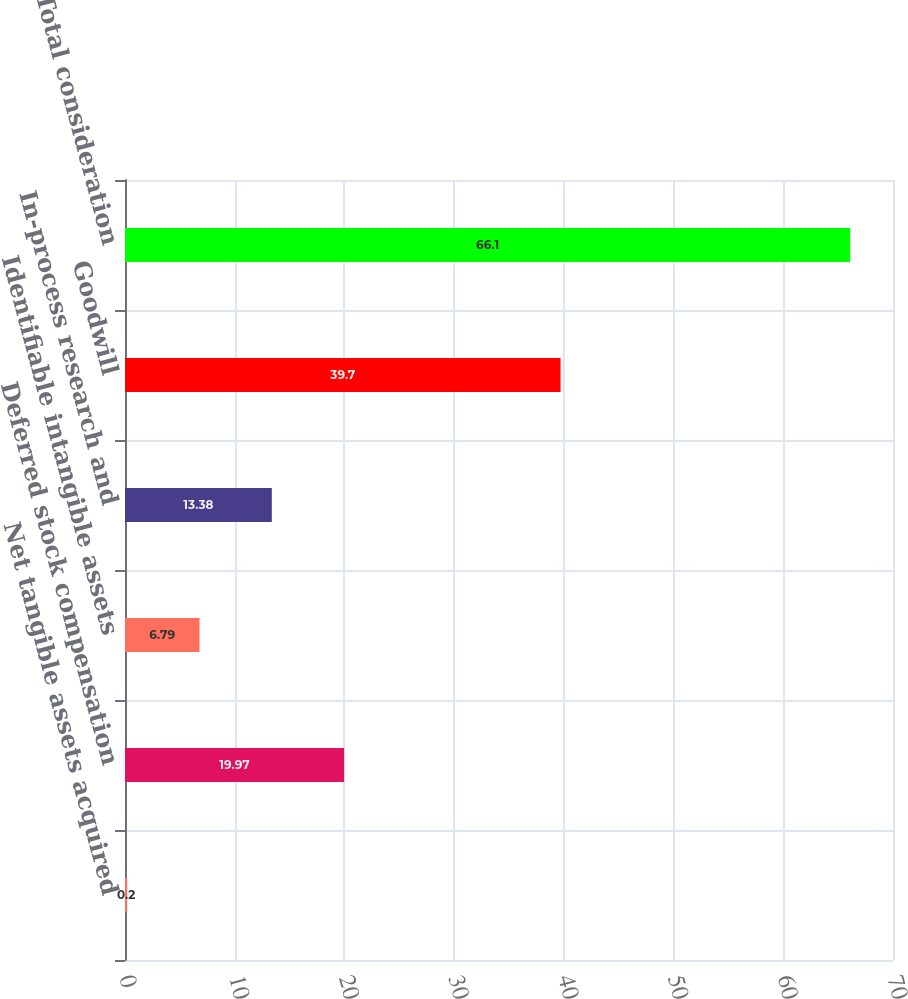<chart> <loc_0><loc_0><loc_500><loc_500><bar_chart><fcel>Net tangible assets acquired<fcel>Deferred stock compensation<fcel>Identifiable intangible assets<fcel>In-process research and<fcel>Goodwill<fcel>Total consideration<nl><fcel>0.2<fcel>19.97<fcel>6.79<fcel>13.38<fcel>39.7<fcel>66.1<nl></chart> 